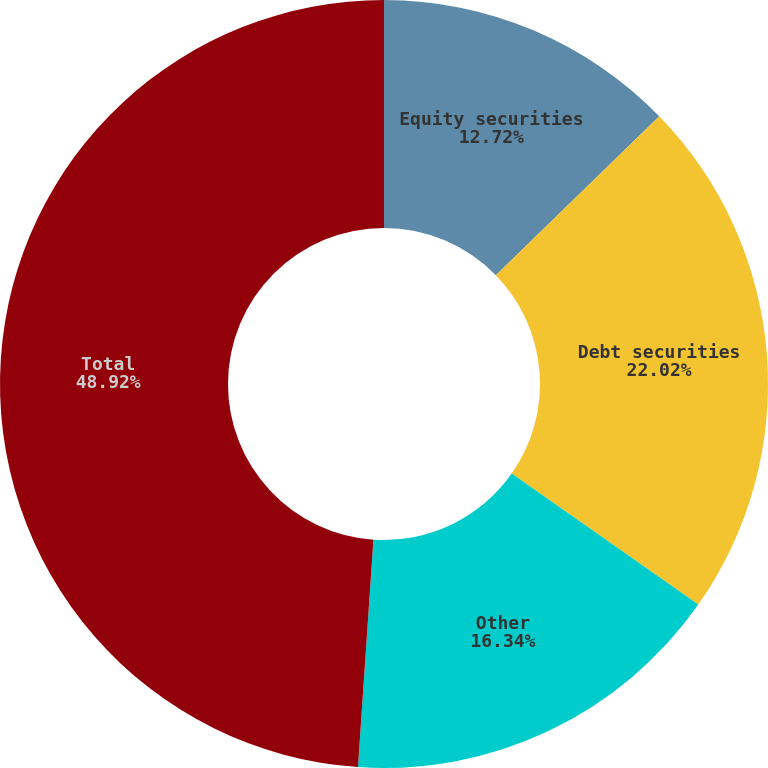Convert chart. <chart><loc_0><loc_0><loc_500><loc_500><pie_chart><fcel>Equity securities<fcel>Debt securities<fcel>Other<fcel>Total<nl><fcel>12.72%<fcel>22.02%<fcel>16.34%<fcel>48.92%<nl></chart> 